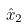Convert formula to latex. <formula><loc_0><loc_0><loc_500><loc_500>\hat { x } _ { 2 }</formula> 